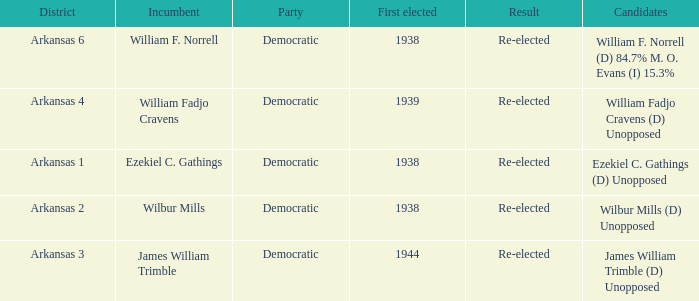Which party has a first elected number bigger than 1939.0? Democratic. 